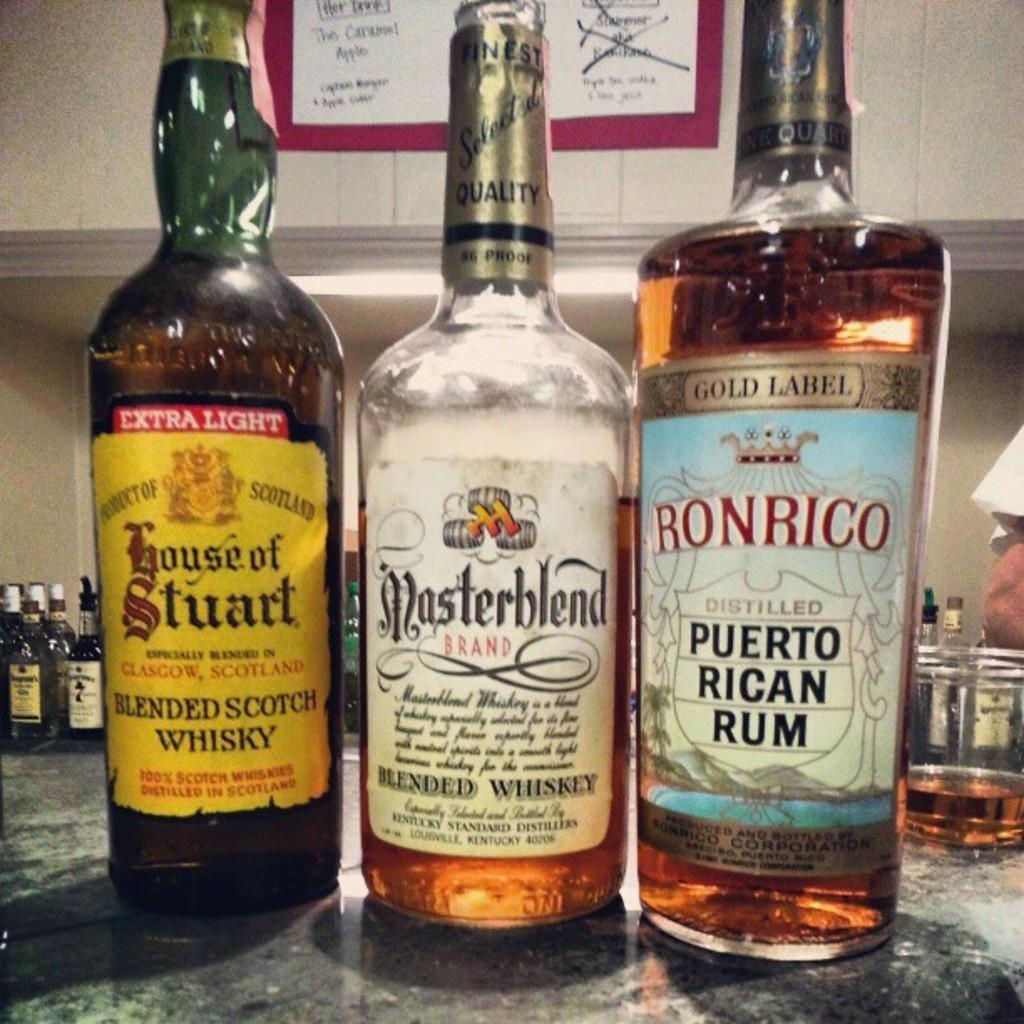How many bottles are visible in the foreground of the image? There are three bottles in the foreground of the image. Can you describe the bottles in the background of the image? There are multiple bottles visible in the background of the image. What type of toys can be seen in the image? There are no toys present in the image; it only features bottles. What kind of building is depicted in the image? There is no building depicted in the image; it only features bottles. 